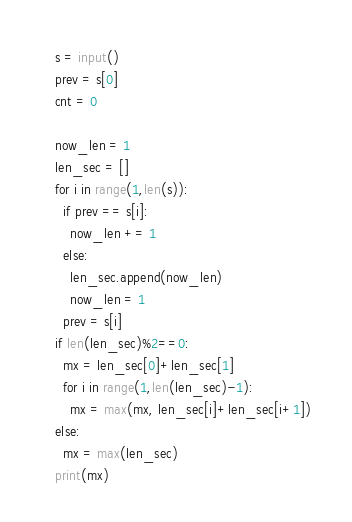<code> <loc_0><loc_0><loc_500><loc_500><_Python_>s = input()
prev = s[0]
cnt = 0

now_len = 1
len_sec = []
for i in range(1,len(s)):
  if prev == s[i]:
    now_len += 1
  else:
    len_sec.append(now_len)
    now_len = 1
  prev = s[i]
if len(len_sec)%2==0:
  mx = len_sec[0]+len_sec[1]
  for i in range(1,len(len_sec)-1):
    mx = max(mx, len_sec[i]+len_sec[i+1])
else:
  mx = max(len_sec)
print(mx)

</code> 